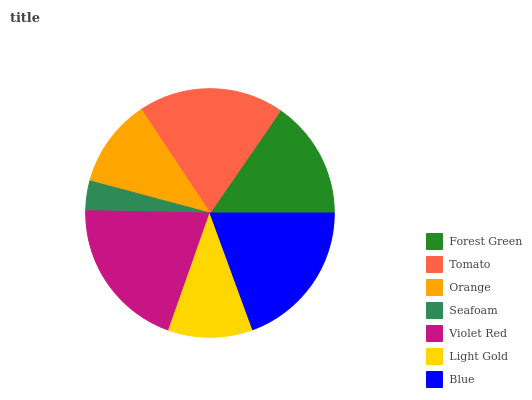Is Seafoam the minimum?
Answer yes or no. Yes. Is Violet Red the maximum?
Answer yes or no. Yes. Is Tomato the minimum?
Answer yes or no. No. Is Tomato the maximum?
Answer yes or no. No. Is Tomato greater than Forest Green?
Answer yes or no. Yes. Is Forest Green less than Tomato?
Answer yes or no. Yes. Is Forest Green greater than Tomato?
Answer yes or no. No. Is Tomato less than Forest Green?
Answer yes or no. No. Is Forest Green the high median?
Answer yes or no. Yes. Is Forest Green the low median?
Answer yes or no. Yes. Is Violet Red the high median?
Answer yes or no. No. Is Seafoam the low median?
Answer yes or no. No. 